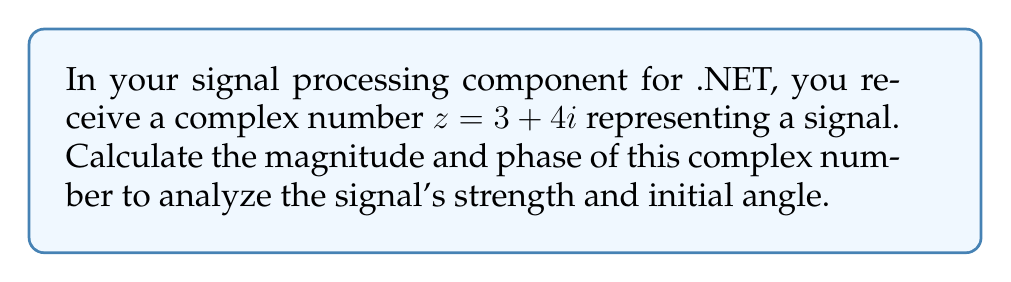Show me your answer to this math problem. To calculate the magnitude and phase of a complex number $z = a + bi$:

1. Magnitude (r):
   The magnitude is given by the formula: $r = \sqrt{a^2 + b^2}$
   For $z = 3 + 4i$:
   $$r = \sqrt{3^2 + 4^2} = \sqrt{9 + 16} = \sqrt{25} = 5$$

2. Phase (θ):
   The phase is given by the formula: $\theta = \arctan(\frac{b}{a})$
   For $z = 3 + 4i$:
   $$\theta = \arctan(\frac{4}{3}) \approx 0.9273 \text{ radians}$$

   To convert radians to degrees:
   $$\theta_{degrees} = \theta_{radians} \times \frac{180°}{\pi} \approx 53.13°$$

Therefore, the magnitude is 5, and the phase is approximately 0.9273 radians or 53.13 degrees.
Answer: Magnitude: 5, Phase: 0.9273 radians (53.13°) 